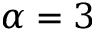<formula> <loc_0><loc_0><loc_500><loc_500>\alpha = 3</formula> 